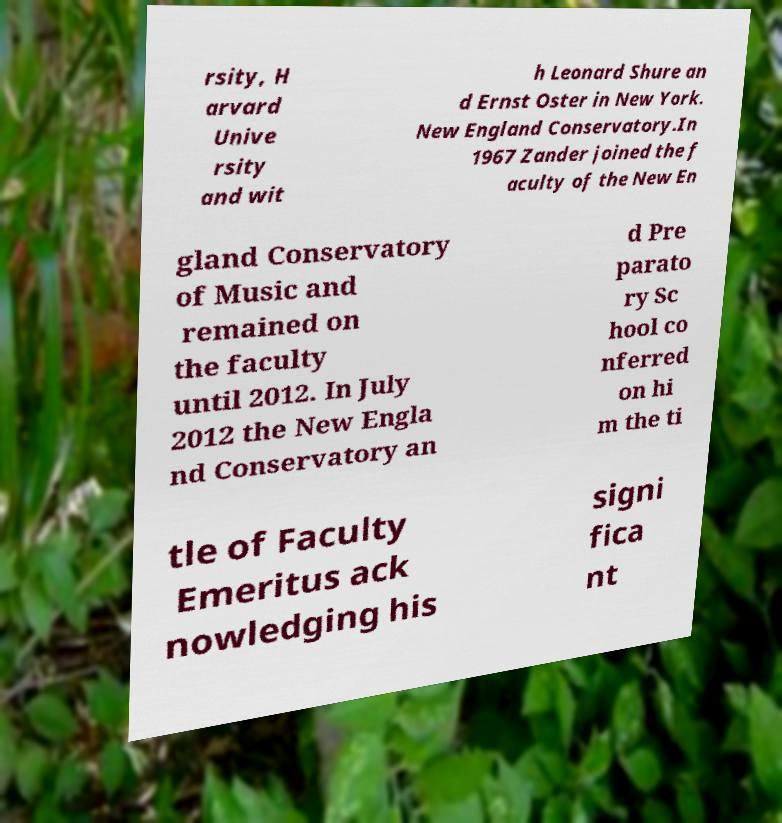I need the written content from this picture converted into text. Can you do that? rsity, H arvard Unive rsity and wit h Leonard Shure an d Ernst Oster in New York. New England Conservatory.In 1967 Zander joined the f aculty of the New En gland Conservatory of Music and remained on the faculty until 2012. In July 2012 the New Engla nd Conservatory an d Pre parato ry Sc hool co nferred on hi m the ti tle of Faculty Emeritus ack nowledging his signi fica nt 